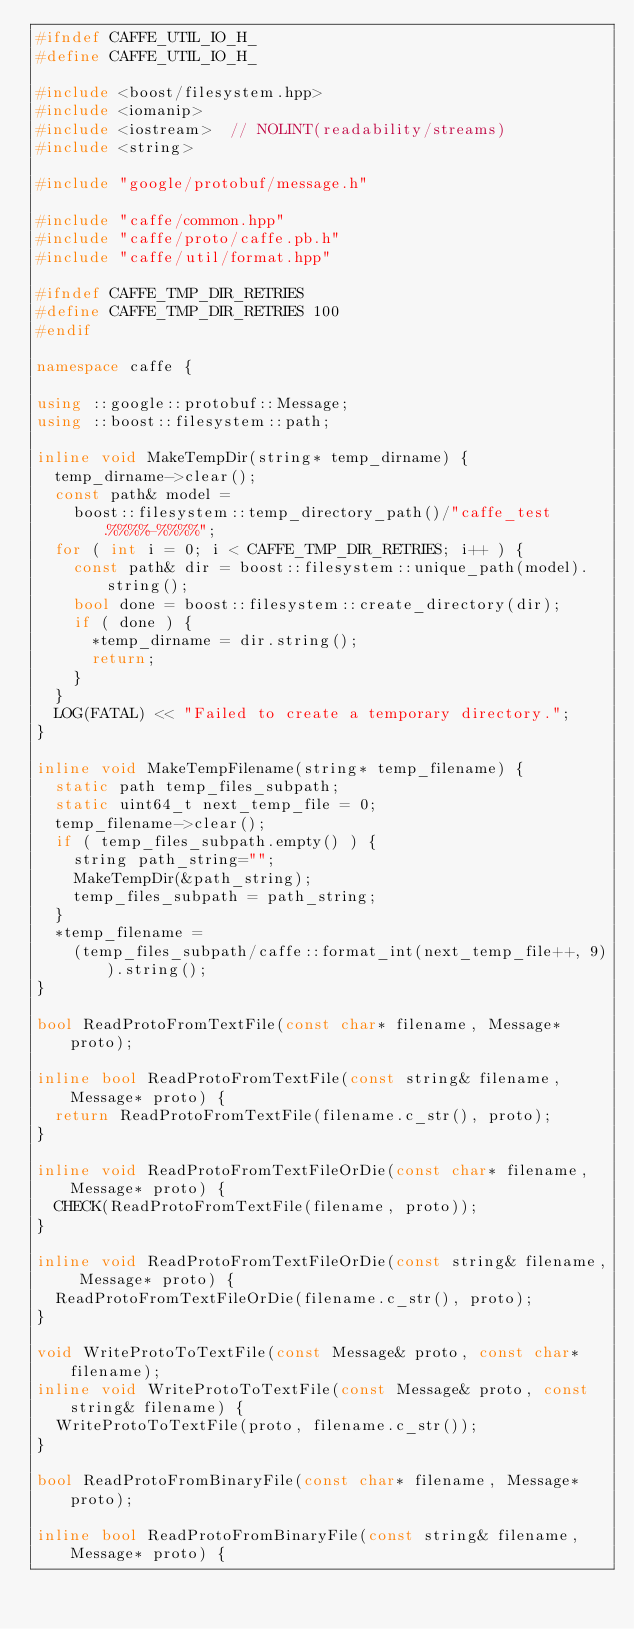<code> <loc_0><loc_0><loc_500><loc_500><_C++_>#ifndef CAFFE_UTIL_IO_H_
#define CAFFE_UTIL_IO_H_

#include <boost/filesystem.hpp>
#include <iomanip>
#include <iostream>  // NOLINT(readability/streams)
#include <string>

#include "google/protobuf/message.h"

#include "caffe/common.hpp"
#include "caffe/proto/caffe.pb.h"
#include "caffe/util/format.hpp"

#ifndef CAFFE_TMP_DIR_RETRIES
#define CAFFE_TMP_DIR_RETRIES 100
#endif

namespace caffe {

using ::google::protobuf::Message;
using ::boost::filesystem::path;

inline void MakeTempDir(string* temp_dirname) {
  temp_dirname->clear();
  const path& model =
    boost::filesystem::temp_directory_path()/"caffe_test.%%%%-%%%%";
  for ( int i = 0; i < CAFFE_TMP_DIR_RETRIES; i++ ) {
    const path& dir = boost::filesystem::unique_path(model).string();
    bool done = boost::filesystem::create_directory(dir);
    if ( done ) {
      *temp_dirname = dir.string();
      return;
    }
  }
  LOG(FATAL) << "Failed to create a temporary directory.";
}

inline void MakeTempFilename(string* temp_filename) {
  static path temp_files_subpath;
  static uint64_t next_temp_file = 0;
  temp_filename->clear();
  if ( temp_files_subpath.empty() ) {
    string path_string="";
    MakeTempDir(&path_string);
    temp_files_subpath = path_string;
  }
  *temp_filename =
    (temp_files_subpath/caffe::format_int(next_temp_file++, 9)).string();
}

bool ReadProtoFromTextFile(const char* filename, Message* proto);

inline bool ReadProtoFromTextFile(const string& filename, Message* proto) {
  return ReadProtoFromTextFile(filename.c_str(), proto);
}

inline void ReadProtoFromTextFileOrDie(const char* filename, Message* proto) {
  CHECK(ReadProtoFromTextFile(filename, proto));
}

inline void ReadProtoFromTextFileOrDie(const string& filename, Message* proto) {
  ReadProtoFromTextFileOrDie(filename.c_str(), proto);
}

void WriteProtoToTextFile(const Message& proto, const char* filename);
inline void WriteProtoToTextFile(const Message& proto, const string& filename) {
  WriteProtoToTextFile(proto, filename.c_str());
}

bool ReadProtoFromBinaryFile(const char* filename, Message* proto);

inline bool ReadProtoFromBinaryFile(const string& filename, Message* proto) {</code> 